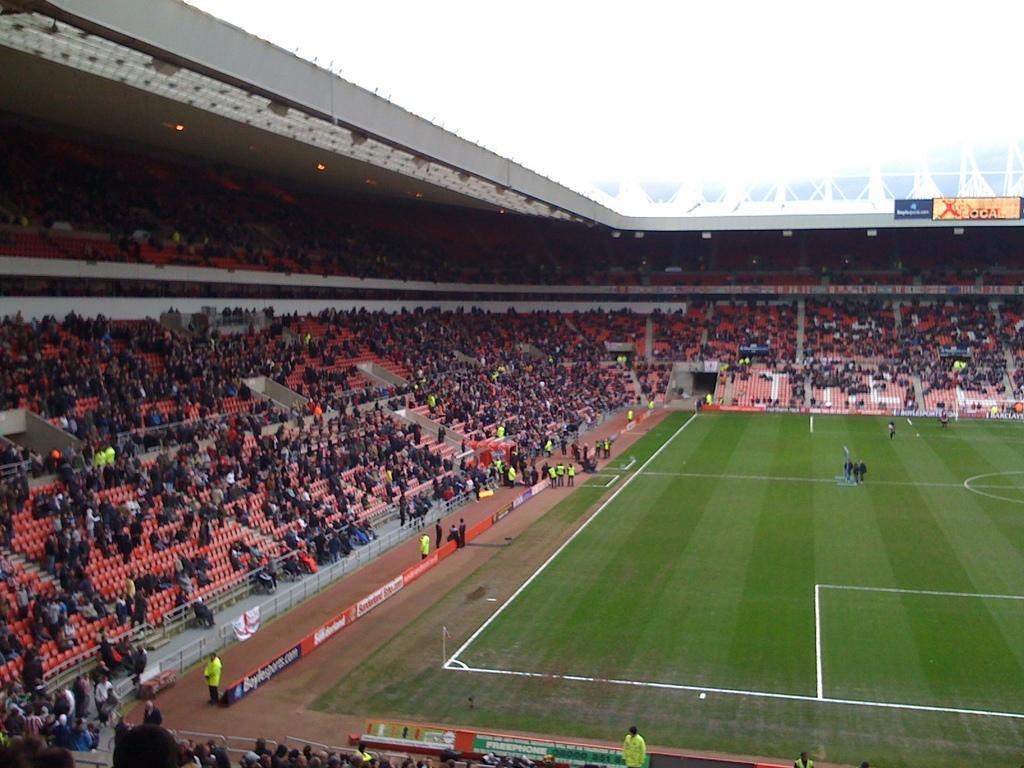Describe this image in one or two sentences. In this image I see the stadium and I see the green grass over here on which there are white lines and I see number of people who are sitting on chairs and I see the lights and I see a board over here and I see it is white in the background. 